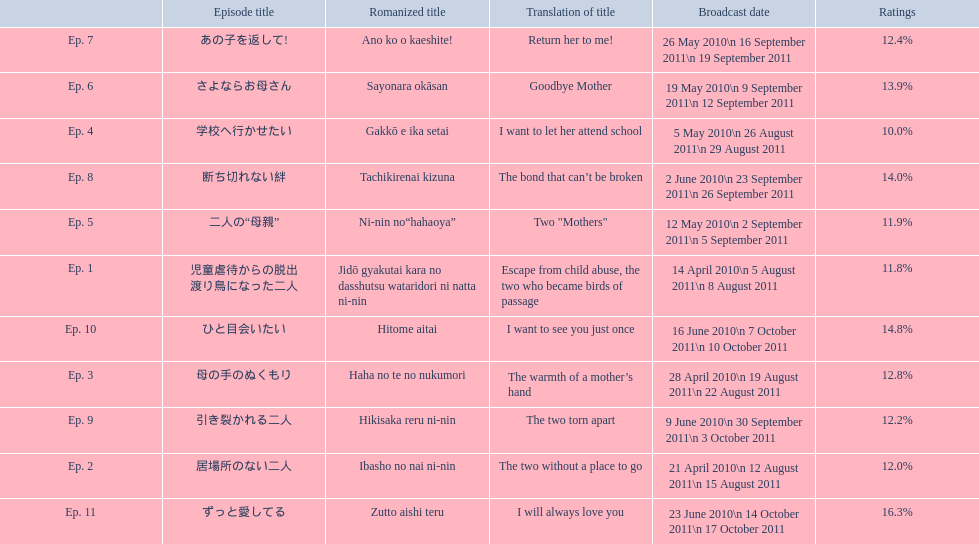What are all of the episode numbers? Ep. 1, Ep. 2, Ep. 3, Ep. 4, Ep. 5, Ep. 6, Ep. 7, Ep. 8, Ep. 9, Ep. 10, Ep. 11. And their titles? 児童虐待からの脱出 渡り鳥になった二人, 居場所のない二人, 母の手のぬくもり, 学校へ行かせたい, 二人の“母親”, さよならお母さん, あの子を返して!, 断ち切れない絆, 引き裂かれる二人, ひと目会いたい, ずっと愛してる. What about their translated names? Escape from child abuse, the two who became birds of passage, The two without a place to go, The warmth of a mother’s hand, I want to let her attend school, Two "Mothers", Goodbye Mother, Return her to me!, The bond that can’t be broken, The two torn apart, I want to see you just once, I will always love you. Which episode number's title translated to i want to let her attend school? Ep. 4. 